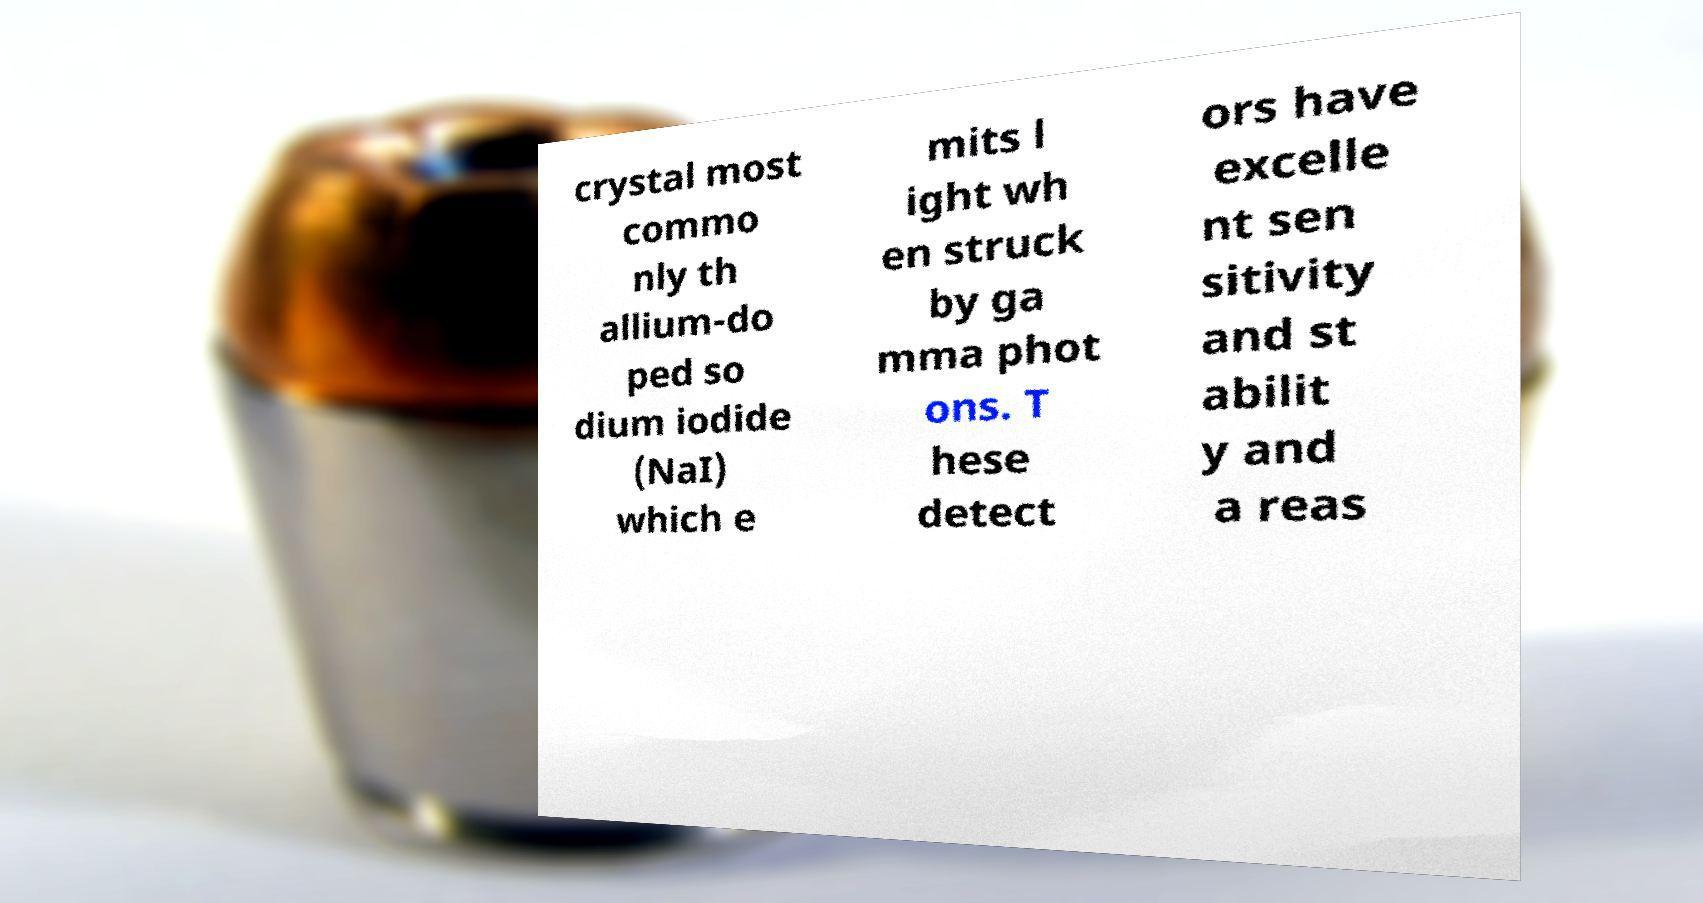There's text embedded in this image that I need extracted. Can you transcribe it verbatim? crystal most commo nly th allium-do ped so dium iodide (NaI) which e mits l ight wh en struck by ga mma phot ons. T hese detect ors have excelle nt sen sitivity and st abilit y and a reas 